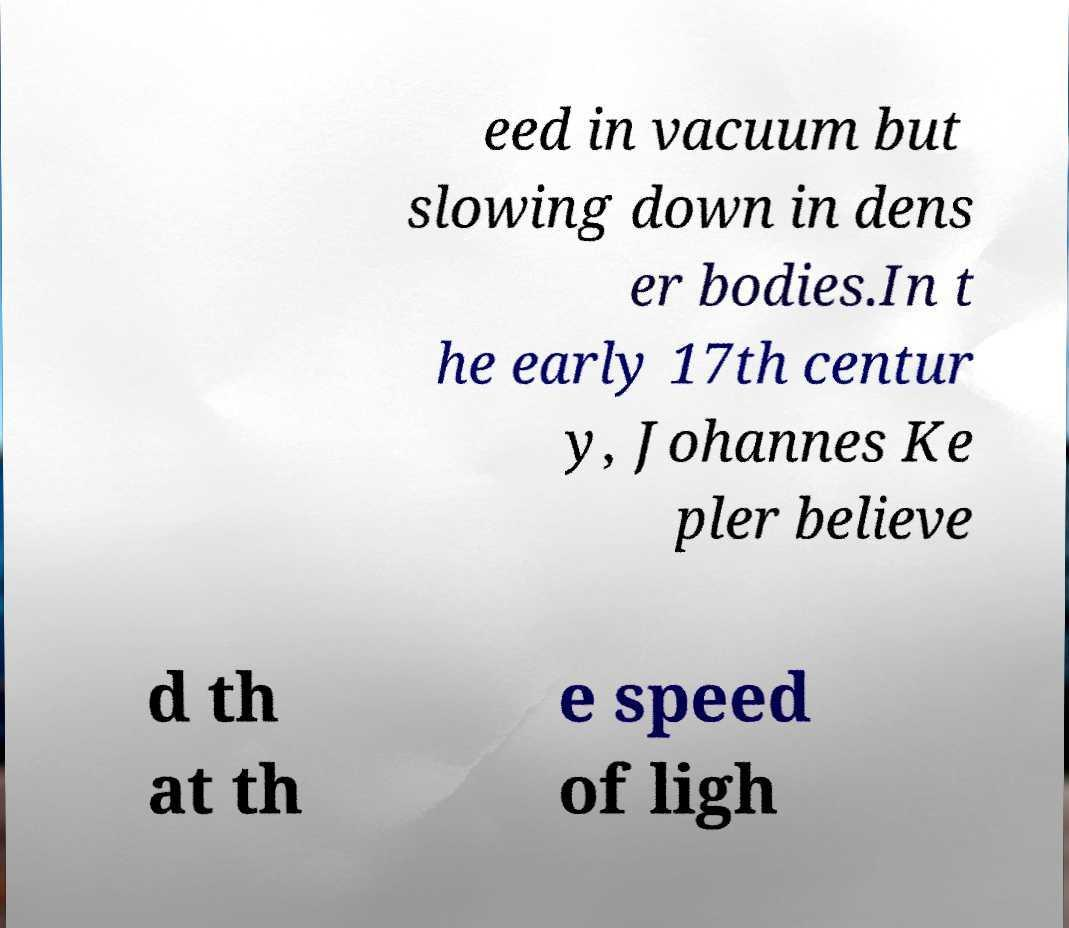Please read and relay the text visible in this image. What does it say? eed in vacuum but slowing down in dens er bodies.In t he early 17th centur y, Johannes Ke pler believe d th at th e speed of ligh 